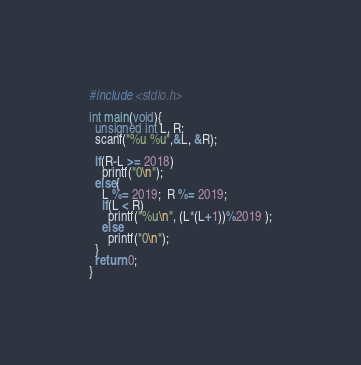Convert code to text. <code><loc_0><loc_0><loc_500><loc_500><_C_>#include <stdio.h>

int main(void){
  unsigned int L, R;
  scanf("%u %u",&L, &R);

  if(R-L >= 2018)
    printf("0\n");
  else{
    L %= 2019;  R %= 2019;
    if(L < R)
      printf("%u\n", (L*(L+1))%2019 );
    else
      printf("0\n");
  }
  return 0;
}
</code> 